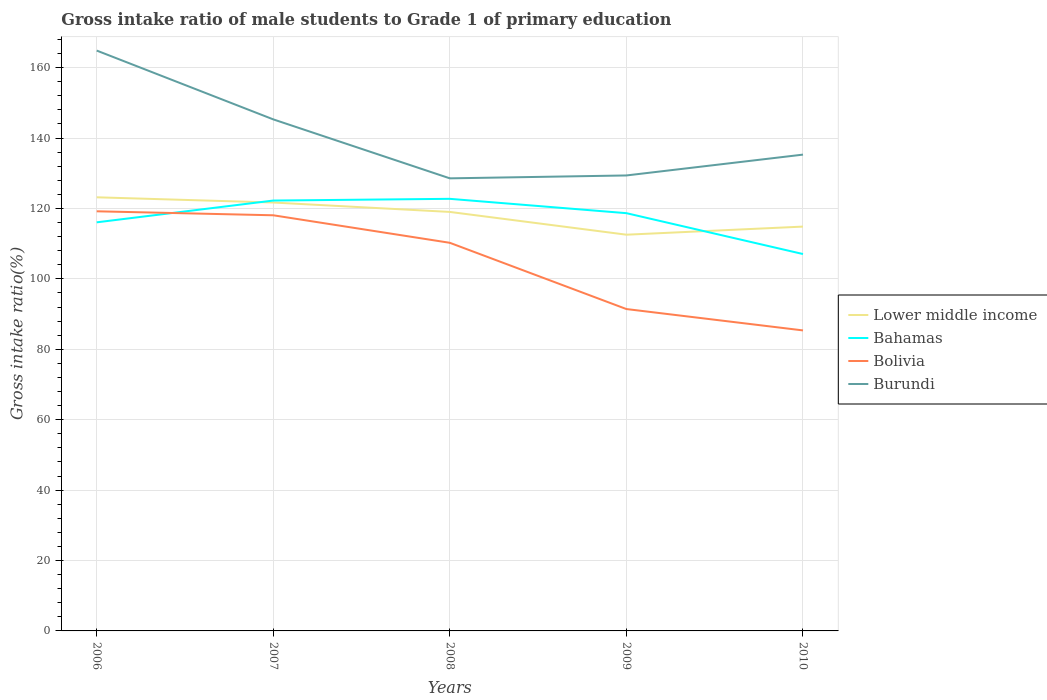How many different coloured lines are there?
Give a very brief answer. 4. Across all years, what is the maximum gross intake ratio in Lower middle income?
Make the answer very short. 112.54. In which year was the gross intake ratio in Bahamas maximum?
Your answer should be very brief. 2010. What is the total gross intake ratio in Lower middle income in the graph?
Ensure brevity in your answer.  9.14. What is the difference between the highest and the second highest gross intake ratio in Bolivia?
Provide a short and direct response. 33.83. Is the gross intake ratio in Bolivia strictly greater than the gross intake ratio in Lower middle income over the years?
Offer a very short reply. Yes. How many lines are there?
Provide a succinct answer. 4. Does the graph contain any zero values?
Offer a terse response. No. How many legend labels are there?
Ensure brevity in your answer.  4. What is the title of the graph?
Offer a terse response. Gross intake ratio of male students to Grade 1 of primary education. Does "Georgia" appear as one of the legend labels in the graph?
Your answer should be very brief. No. What is the label or title of the Y-axis?
Your answer should be very brief. Gross intake ratio(%). What is the Gross intake ratio(%) in Lower middle income in 2006?
Ensure brevity in your answer.  123.17. What is the Gross intake ratio(%) of Bahamas in 2006?
Your answer should be very brief. 116.06. What is the Gross intake ratio(%) in Bolivia in 2006?
Offer a terse response. 119.19. What is the Gross intake ratio(%) in Burundi in 2006?
Ensure brevity in your answer.  164.85. What is the Gross intake ratio(%) of Lower middle income in 2007?
Give a very brief answer. 121.68. What is the Gross intake ratio(%) of Bahamas in 2007?
Give a very brief answer. 122.25. What is the Gross intake ratio(%) in Bolivia in 2007?
Provide a short and direct response. 118.06. What is the Gross intake ratio(%) in Burundi in 2007?
Offer a very short reply. 145.3. What is the Gross intake ratio(%) of Lower middle income in 2008?
Keep it short and to the point. 119.01. What is the Gross intake ratio(%) in Bahamas in 2008?
Offer a terse response. 122.73. What is the Gross intake ratio(%) of Bolivia in 2008?
Your answer should be very brief. 110.24. What is the Gross intake ratio(%) of Burundi in 2008?
Your answer should be compact. 128.55. What is the Gross intake ratio(%) in Lower middle income in 2009?
Your response must be concise. 112.54. What is the Gross intake ratio(%) in Bahamas in 2009?
Provide a succinct answer. 118.66. What is the Gross intake ratio(%) of Bolivia in 2009?
Make the answer very short. 91.42. What is the Gross intake ratio(%) in Burundi in 2009?
Your answer should be compact. 129.37. What is the Gross intake ratio(%) of Lower middle income in 2010?
Offer a terse response. 114.85. What is the Gross intake ratio(%) in Bahamas in 2010?
Your answer should be very brief. 107.05. What is the Gross intake ratio(%) of Bolivia in 2010?
Give a very brief answer. 85.36. What is the Gross intake ratio(%) of Burundi in 2010?
Your answer should be compact. 135.29. Across all years, what is the maximum Gross intake ratio(%) in Lower middle income?
Make the answer very short. 123.17. Across all years, what is the maximum Gross intake ratio(%) of Bahamas?
Your answer should be compact. 122.73. Across all years, what is the maximum Gross intake ratio(%) of Bolivia?
Provide a short and direct response. 119.19. Across all years, what is the maximum Gross intake ratio(%) in Burundi?
Make the answer very short. 164.85. Across all years, what is the minimum Gross intake ratio(%) in Lower middle income?
Your answer should be very brief. 112.54. Across all years, what is the minimum Gross intake ratio(%) of Bahamas?
Your answer should be compact. 107.05. Across all years, what is the minimum Gross intake ratio(%) in Bolivia?
Offer a very short reply. 85.36. Across all years, what is the minimum Gross intake ratio(%) of Burundi?
Your answer should be compact. 128.55. What is the total Gross intake ratio(%) in Lower middle income in the graph?
Your answer should be compact. 591.25. What is the total Gross intake ratio(%) in Bahamas in the graph?
Give a very brief answer. 586.74. What is the total Gross intake ratio(%) in Bolivia in the graph?
Offer a very short reply. 524.27. What is the total Gross intake ratio(%) of Burundi in the graph?
Your answer should be compact. 703.36. What is the difference between the Gross intake ratio(%) of Lower middle income in 2006 and that in 2007?
Keep it short and to the point. 1.49. What is the difference between the Gross intake ratio(%) in Bahamas in 2006 and that in 2007?
Your answer should be compact. -6.19. What is the difference between the Gross intake ratio(%) in Bolivia in 2006 and that in 2007?
Offer a very short reply. 1.13. What is the difference between the Gross intake ratio(%) of Burundi in 2006 and that in 2007?
Keep it short and to the point. 19.55. What is the difference between the Gross intake ratio(%) in Lower middle income in 2006 and that in 2008?
Your answer should be compact. 4.16. What is the difference between the Gross intake ratio(%) of Bahamas in 2006 and that in 2008?
Offer a very short reply. -6.67. What is the difference between the Gross intake ratio(%) of Bolivia in 2006 and that in 2008?
Make the answer very short. 8.95. What is the difference between the Gross intake ratio(%) in Burundi in 2006 and that in 2008?
Provide a succinct answer. 36.29. What is the difference between the Gross intake ratio(%) of Lower middle income in 2006 and that in 2009?
Ensure brevity in your answer.  10.63. What is the difference between the Gross intake ratio(%) of Bahamas in 2006 and that in 2009?
Keep it short and to the point. -2.6. What is the difference between the Gross intake ratio(%) in Bolivia in 2006 and that in 2009?
Offer a terse response. 27.77. What is the difference between the Gross intake ratio(%) in Burundi in 2006 and that in 2009?
Offer a terse response. 35.47. What is the difference between the Gross intake ratio(%) in Lower middle income in 2006 and that in 2010?
Offer a terse response. 8.32. What is the difference between the Gross intake ratio(%) of Bahamas in 2006 and that in 2010?
Your answer should be compact. 9.01. What is the difference between the Gross intake ratio(%) in Bolivia in 2006 and that in 2010?
Keep it short and to the point. 33.83. What is the difference between the Gross intake ratio(%) of Burundi in 2006 and that in 2010?
Provide a succinct answer. 29.56. What is the difference between the Gross intake ratio(%) in Lower middle income in 2007 and that in 2008?
Provide a succinct answer. 2.67. What is the difference between the Gross intake ratio(%) of Bahamas in 2007 and that in 2008?
Provide a short and direct response. -0.48. What is the difference between the Gross intake ratio(%) of Bolivia in 2007 and that in 2008?
Your answer should be very brief. 7.82. What is the difference between the Gross intake ratio(%) of Burundi in 2007 and that in 2008?
Keep it short and to the point. 16.75. What is the difference between the Gross intake ratio(%) in Lower middle income in 2007 and that in 2009?
Your answer should be compact. 9.14. What is the difference between the Gross intake ratio(%) of Bahamas in 2007 and that in 2009?
Ensure brevity in your answer.  3.59. What is the difference between the Gross intake ratio(%) in Bolivia in 2007 and that in 2009?
Provide a succinct answer. 26.64. What is the difference between the Gross intake ratio(%) in Burundi in 2007 and that in 2009?
Make the answer very short. 15.92. What is the difference between the Gross intake ratio(%) in Lower middle income in 2007 and that in 2010?
Provide a succinct answer. 6.84. What is the difference between the Gross intake ratio(%) in Bahamas in 2007 and that in 2010?
Make the answer very short. 15.2. What is the difference between the Gross intake ratio(%) in Bolivia in 2007 and that in 2010?
Keep it short and to the point. 32.7. What is the difference between the Gross intake ratio(%) of Burundi in 2007 and that in 2010?
Offer a very short reply. 10.01. What is the difference between the Gross intake ratio(%) of Lower middle income in 2008 and that in 2009?
Give a very brief answer. 6.47. What is the difference between the Gross intake ratio(%) in Bahamas in 2008 and that in 2009?
Make the answer very short. 4.07. What is the difference between the Gross intake ratio(%) in Bolivia in 2008 and that in 2009?
Make the answer very short. 18.82. What is the difference between the Gross intake ratio(%) of Burundi in 2008 and that in 2009?
Your answer should be very brief. -0.82. What is the difference between the Gross intake ratio(%) in Lower middle income in 2008 and that in 2010?
Your answer should be compact. 4.17. What is the difference between the Gross intake ratio(%) of Bahamas in 2008 and that in 2010?
Your response must be concise. 15.68. What is the difference between the Gross intake ratio(%) of Bolivia in 2008 and that in 2010?
Make the answer very short. 24.88. What is the difference between the Gross intake ratio(%) in Burundi in 2008 and that in 2010?
Offer a terse response. -6.74. What is the difference between the Gross intake ratio(%) in Lower middle income in 2009 and that in 2010?
Give a very brief answer. -2.3. What is the difference between the Gross intake ratio(%) of Bahamas in 2009 and that in 2010?
Your response must be concise. 11.61. What is the difference between the Gross intake ratio(%) of Bolivia in 2009 and that in 2010?
Ensure brevity in your answer.  6.06. What is the difference between the Gross intake ratio(%) of Burundi in 2009 and that in 2010?
Give a very brief answer. -5.92. What is the difference between the Gross intake ratio(%) in Lower middle income in 2006 and the Gross intake ratio(%) in Bahamas in 2007?
Keep it short and to the point. 0.92. What is the difference between the Gross intake ratio(%) in Lower middle income in 2006 and the Gross intake ratio(%) in Bolivia in 2007?
Give a very brief answer. 5.11. What is the difference between the Gross intake ratio(%) in Lower middle income in 2006 and the Gross intake ratio(%) in Burundi in 2007?
Offer a very short reply. -22.13. What is the difference between the Gross intake ratio(%) in Bahamas in 2006 and the Gross intake ratio(%) in Bolivia in 2007?
Your response must be concise. -2. What is the difference between the Gross intake ratio(%) of Bahamas in 2006 and the Gross intake ratio(%) of Burundi in 2007?
Ensure brevity in your answer.  -29.24. What is the difference between the Gross intake ratio(%) in Bolivia in 2006 and the Gross intake ratio(%) in Burundi in 2007?
Offer a terse response. -26.11. What is the difference between the Gross intake ratio(%) of Lower middle income in 2006 and the Gross intake ratio(%) of Bahamas in 2008?
Give a very brief answer. 0.44. What is the difference between the Gross intake ratio(%) of Lower middle income in 2006 and the Gross intake ratio(%) of Bolivia in 2008?
Ensure brevity in your answer.  12.93. What is the difference between the Gross intake ratio(%) in Lower middle income in 2006 and the Gross intake ratio(%) in Burundi in 2008?
Your answer should be very brief. -5.38. What is the difference between the Gross intake ratio(%) in Bahamas in 2006 and the Gross intake ratio(%) in Bolivia in 2008?
Keep it short and to the point. 5.82. What is the difference between the Gross intake ratio(%) of Bahamas in 2006 and the Gross intake ratio(%) of Burundi in 2008?
Offer a very short reply. -12.49. What is the difference between the Gross intake ratio(%) of Bolivia in 2006 and the Gross intake ratio(%) of Burundi in 2008?
Make the answer very short. -9.36. What is the difference between the Gross intake ratio(%) in Lower middle income in 2006 and the Gross intake ratio(%) in Bahamas in 2009?
Make the answer very short. 4.51. What is the difference between the Gross intake ratio(%) in Lower middle income in 2006 and the Gross intake ratio(%) in Bolivia in 2009?
Provide a succinct answer. 31.75. What is the difference between the Gross intake ratio(%) of Lower middle income in 2006 and the Gross intake ratio(%) of Burundi in 2009?
Give a very brief answer. -6.2. What is the difference between the Gross intake ratio(%) in Bahamas in 2006 and the Gross intake ratio(%) in Bolivia in 2009?
Your response must be concise. 24.64. What is the difference between the Gross intake ratio(%) in Bahamas in 2006 and the Gross intake ratio(%) in Burundi in 2009?
Offer a terse response. -13.32. What is the difference between the Gross intake ratio(%) in Bolivia in 2006 and the Gross intake ratio(%) in Burundi in 2009?
Provide a succinct answer. -10.18. What is the difference between the Gross intake ratio(%) in Lower middle income in 2006 and the Gross intake ratio(%) in Bahamas in 2010?
Offer a very short reply. 16.12. What is the difference between the Gross intake ratio(%) in Lower middle income in 2006 and the Gross intake ratio(%) in Bolivia in 2010?
Your answer should be compact. 37.81. What is the difference between the Gross intake ratio(%) in Lower middle income in 2006 and the Gross intake ratio(%) in Burundi in 2010?
Your response must be concise. -12.12. What is the difference between the Gross intake ratio(%) of Bahamas in 2006 and the Gross intake ratio(%) of Bolivia in 2010?
Make the answer very short. 30.7. What is the difference between the Gross intake ratio(%) in Bahamas in 2006 and the Gross intake ratio(%) in Burundi in 2010?
Ensure brevity in your answer.  -19.23. What is the difference between the Gross intake ratio(%) in Bolivia in 2006 and the Gross intake ratio(%) in Burundi in 2010?
Your response must be concise. -16.1. What is the difference between the Gross intake ratio(%) of Lower middle income in 2007 and the Gross intake ratio(%) of Bahamas in 2008?
Provide a short and direct response. -1.05. What is the difference between the Gross intake ratio(%) in Lower middle income in 2007 and the Gross intake ratio(%) in Bolivia in 2008?
Your answer should be very brief. 11.44. What is the difference between the Gross intake ratio(%) in Lower middle income in 2007 and the Gross intake ratio(%) in Burundi in 2008?
Ensure brevity in your answer.  -6.87. What is the difference between the Gross intake ratio(%) in Bahamas in 2007 and the Gross intake ratio(%) in Bolivia in 2008?
Provide a succinct answer. 12.01. What is the difference between the Gross intake ratio(%) in Bahamas in 2007 and the Gross intake ratio(%) in Burundi in 2008?
Offer a terse response. -6.3. What is the difference between the Gross intake ratio(%) of Bolivia in 2007 and the Gross intake ratio(%) of Burundi in 2008?
Offer a very short reply. -10.49. What is the difference between the Gross intake ratio(%) in Lower middle income in 2007 and the Gross intake ratio(%) in Bahamas in 2009?
Offer a very short reply. 3.02. What is the difference between the Gross intake ratio(%) of Lower middle income in 2007 and the Gross intake ratio(%) of Bolivia in 2009?
Your answer should be very brief. 30.26. What is the difference between the Gross intake ratio(%) of Lower middle income in 2007 and the Gross intake ratio(%) of Burundi in 2009?
Give a very brief answer. -7.69. What is the difference between the Gross intake ratio(%) in Bahamas in 2007 and the Gross intake ratio(%) in Bolivia in 2009?
Keep it short and to the point. 30.82. What is the difference between the Gross intake ratio(%) of Bahamas in 2007 and the Gross intake ratio(%) of Burundi in 2009?
Your answer should be compact. -7.13. What is the difference between the Gross intake ratio(%) in Bolivia in 2007 and the Gross intake ratio(%) in Burundi in 2009?
Keep it short and to the point. -11.32. What is the difference between the Gross intake ratio(%) in Lower middle income in 2007 and the Gross intake ratio(%) in Bahamas in 2010?
Ensure brevity in your answer.  14.63. What is the difference between the Gross intake ratio(%) in Lower middle income in 2007 and the Gross intake ratio(%) in Bolivia in 2010?
Provide a short and direct response. 36.33. What is the difference between the Gross intake ratio(%) in Lower middle income in 2007 and the Gross intake ratio(%) in Burundi in 2010?
Make the answer very short. -13.61. What is the difference between the Gross intake ratio(%) of Bahamas in 2007 and the Gross intake ratio(%) of Bolivia in 2010?
Give a very brief answer. 36.89. What is the difference between the Gross intake ratio(%) in Bahamas in 2007 and the Gross intake ratio(%) in Burundi in 2010?
Provide a short and direct response. -13.04. What is the difference between the Gross intake ratio(%) of Bolivia in 2007 and the Gross intake ratio(%) of Burundi in 2010?
Offer a very short reply. -17.23. What is the difference between the Gross intake ratio(%) of Lower middle income in 2008 and the Gross intake ratio(%) of Bahamas in 2009?
Provide a short and direct response. 0.35. What is the difference between the Gross intake ratio(%) of Lower middle income in 2008 and the Gross intake ratio(%) of Bolivia in 2009?
Keep it short and to the point. 27.59. What is the difference between the Gross intake ratio(%) of Lower middle income in 2008 and the Gross intake ratio(%) of Burundi in 2009?
Offer a very short reply. -10.36. What is the difference between the Gross intake ratio(%) in Bahamas in 2008 and the Gross intake ratio(%) in Bolivia in 2009?
Offer a terse response. 31.31. What is the difference between the Gross intake ratio(%) in Bahamas in 2008 and the Gross intake ratio(%) in Burundi in 2009?
Your answer should be very brief. -6.64. What is the difference between the Gross intake ratio(%) of Bolivia in 2008 and the Gross intake ratio(%) of Burundi in 2009?
Make the answer very short. -19.13. What is the difference between the Gross intake ratio(%) in Lower middle income in 2008 and the Gross intake ratio(%) in Bahamas in 2010?
Make the answer very short. 11.96. What is the difference between the Gross intake ratio(%) in Lower middle income in 2008 and the Gross intake ratio(%) in Bolivia in 2010?
Give a very brief answer. 33.65. What is the difference between the Gross intake ratio(%) in Lower middle income in 2008 and the Gross intake ratio(%) in Burundi in 2010?
Provide a succinct answer. -16.28. What is the difference between the Gross intake ratio(%) of Bahamas in 2008 and the Gross intake ratio(%) of Bolivia in 2010?
Provide a succinct answer. 37.37. What is the difference between the Gross intake ratio(%) in Bahamas in 2008 and the Gross intake ratio(%) in Burundi in 2010?
Offer a terse response. -12.56. What is the difference between the Gross intake ratio(%) in Bolivia in 2008 and the Gross intake ratio(%) in Burundi in 2010?
Keep it short and to the point. -25.05. What is the difference between the Gross intake ratio(%) in Lower middle income in 2009 and the Gross intake ratio(%) in Bahamas in 2010?
Your answer should be very brief. 5.49. What is the difference between the Gross intake ratio(%) of Lower middle income in 2009 and the Gross intake ratio(%) of Bolivia in 2010?
Give a very brief answer. 27.19. What is the difference between the Gross intake ratio(%) of Lower middle income in 2009 and the Gross intake ratio(%) of Burundi in 2010?
Offer a very short reply. -22.75. What is the difference between the Gross intake ratio(%) of Bahamas in 2009 and the Gross intake ratio(%) of Bolivia in 2010?
Provide a short and direct response. 33.3. What is the difference between the Gross intake ratio(%) of Bahamas in 2009 and the Gross intake ratio(%) of Burundi in 2010?
Your answer should be very brief. -16.63. What is the difference between the Gross intake ratio(%) in Bolivia in 2009 and the Gross intake ratio(%) in Burundi in 2010?
Ensure brevity in your answer.  -43.87. What is the average Gross intake ratio(%) of Lower middle income per year?
Offer a very short reply. 118.25. What is the average Gross intake ratio(%) in Bahamas per year?
Your response must be concise. 117.35. What is the average Gross intake ratio(%) of Bolivia per year?
Keep it short and to the point. 104.85. What is the average Gross intake ratio(%) of Burundi per year?
Ensure brevity in your answer.  140.67. In the year 2006, what is the difference between the Gross intake ratio(%) in Lower middle income and Gross intake ratio(%) in Bahamas?
Ensure brevity in your answer.  7.11. In the year 2006, what is the difference between the Gross intake ratio(%) in Lower middle income and Gross intake ratio(%) in Bolivia?
Your answer should be very brief. 3.98. In the year 2006, what is the difference between the Gross intake ratio(%) in Lower middle income and Gross intake ratio(%) in Burundi?
Keep it short and to the point. -41.68. In the year 2006, what is the difference between the Gross intake ratio(%) of Bahamas and Gross intake ratio(%) of Bolivia?
Your response must be concise. -3.13. In the year 2006, what is the difference between the Gross intake ratio(%) of Bahamas and Gross intake ratio(%) of Burundi?
Offer a very short reply. -48.79. In the year 2006, what is the difference between the Gross intake ratio(%) in Bolivia and Gross intake ratio(%) in Burundi?
Keep it short and to the point. -45.65. In the year 2007, what is the difference between the Gross intake ratio(%) of Lower middle income and Gross intake ratio(%) of Bahamas?
Your answer should be very brief. -0.56. In the year 2007, what is the difference between the Gross intake ratio(%) of Lower middle income and Gross intake ratio(%) of Bolivia?
Your response must be concise. 3.62. In the year 2007, what is the difference between the Gross intake ratio(%) of Lower middle income and Gross intake ratio(%) of Burundi?
Your response must be concise. -23.62. In the year 2007, what is the difference between the Gross intake ratio(%) in Bahamas and Gross intake ratio(%) in Bolivia?
Make the answer very short. 4.19. In the year 2007, what is the difference between the Gross intake ratio(%) of Bahamas and Gross intake ratio(%) of Burundi?
Offer a very short reply. -23.05. In the year 2007, what is the difference between the Gross intake ratio(%) in Bolivia and Gross intake ratio(%) in Burundi?
Give a very brief answer. -27.24. In the year 2008, what is the difference between the Gross intake ratio(%) in Lower middle income and Gross intake ratio(%) in Bahamas?
Make the answer very short. -3.72. In the year 2008, what is the difference between the Gross intake ratio(%) of Lower middle income and Gross intake ratio(%) of Bolivia?
Provide a succinct answer. 8.77. In the year 2008, what is the difference between the Gross intake ratio(%) in Lower middle income and Gross intake ratio(%) in Burundi?
Your answer should be very brief. -9.54. In the year 2008, what is the difference between the Gross intake ratio(%) of Bahamas and Gross intake ratio(%) of Bolivia?
Provide a short and direct response. 12.49. In the year 2008, what is the difference between the Gross intake ratio(%) of Bahamas and Gross intake ratio(%) of Burundi?
Your response must be concise. -5.82. In the year 2008, what is the difference between the Gross intake ratio(%) of Bolivia and Gross intake ratio(%) of Burundi?
Your answer should be very brief. -18.31. In the year 2009, what is the difference between the Gross intake ratio(%) in Lower middle income and Gross intake ratio(%) in Bahamas?
Offer a terse response. -6.12. In the year 2009, what is the difference between the Gross intake ratio(%) of Lower middle income and Gross intake ratio(%) of Bolivia?
Provide a short and direct response. 21.12. In the year 2009, what is the difference between the Gross intake ratio(%) in Lower middle income and Gross intake ratio(%) in Burundi?
Offer a very short reply. -16.83. In the year 2009, what is the difference between the Gross intake ratio(%) of Bahamas and Gross intake ratio(%) of Bolivia?
Provide a succinct answer. 27.24. In the year 2009, what is the difference between the Gross intake ratio(%) in Bahamas and Gross intake ratio(%) in Burundi?
Provide a short and direct response. -10.72. In the year 2009, what is the difference between the Gross intake ratio(%) in Bolivia and Gross intake ratio(%) in Burundi?
Provide a short and direct response. -37.95. In the year 2010, what is the difference between the Gross intake ratio(%) of Lower middle income and Gross intake ratio(%) of Bahamas?
Provide a short and direct response. 7.8. In the year 2010, what is the difference between the Gross intake ratio(%) of Lower middle income and Gross intake ratio(%) of Bolivia?
Keep it short and to the point. 29.49. In the year 2010, what is the difference between the Gross intake ratio(%) in Lower middle income and Gross intake ratio(%) in Burundi?
Your response must be concise. -20.44. In the year 2010, what is the difference between the Gross intake ratio(%) of Bahamas and Gross intake ratio(%) of Bolivia?
Ensure brevity in your answer.  21.69. In the year 2010, what is the difference between the Gross intake ratio(%) in Bahamas and Gross intake ratio(%) in Burundi?
Your answer should be very brief. -28.24. In the year 2010, what is the difference between the Gross intake ratio(%) of Bolivia and Gross intake ratio(%) of Burundi?
Offer a very short reply. -49.93. What is the ratio of the Gross intake ratio(%) of Lower middle income in 2006 to that in 2007?
Give a very brief answer. 1.01. What is the ratio of the Gross intake ratio(%) in Bahamas in 2006 to that in 2007?
Give a very brief answer. 0.95. What is the ratio of the Gross intake ratio(%) of Bolivia in 2006 to that in 2007?
Your response must be concise. 1.01. What is the ratio of the Gross intake ratio(%) in Burundi in 2006 to that in 2007?
Give a very brief answer. 1.13. What is the ratio of the Gross intake ratio(%) in Lower middle income in 2006 to that in 2008?
Offer a very short reply. 1.03. What is the ratio of the Gross intake ratio(%) in Bahamas in 2006 to that in 2008?
Make the answer very short. 0.95. What is the ratio of the Gross intake ratio(%) in Bolivia in 2006 to that in 2008?
Ensure brevity in your answer.  1.08. What is the ratio of the Gross intake ratio(%) of Burundi in 2006 to that in 2008?
Offer a terse response. 1.28. What is the ratio of the Gross intake ratio(%) of Lower middle income in 2006 to that in 2009?
Make the answer very short. 1.09. What is the ratio of the Gross intake ratio(%) of Bahamas in 2006 to that in 2009?
Your answer should be compact. 0.98. What is the ratio of the Gross intake ratio(%) of Bolivia in 2006 to that in 2009?
Offer a terse response. 1.3. What is the ratio of the Gross intake ratio(%) in Burundi in 2006 to that in 2009?
Your answer should be compact. 1.27. What is the ratio of the Gross intake ratio(%) of Lower middle income in 2006 to that in 2010?
Provide a succinct answer. 1.07. What is the ratio of the Gross intake ratio(%) in Bahamas in 2006 to that in 2010?
Ensure brevity in your answer.  1.08. What is the ratio of the Gross intake ratio(%) in Bolivia in 2006 to that in 2010?
Offer a very short reply. 1.4. What is the ratio of the Gross intake ratio(%) in Burundi in 2006 to that in 2010?
Your answer should be very brief. 1.22. What is the ratio of the Gross intake ratio(%) in Lower middle income in 2007 to that in 2008?
Make the answer very short. 1.02. What is the ratio of the Gross intake ratio(%) of Bahamas in 2007 to that in 2008?
Offer a very short reply. 1. What is the ratio of the Gross intake ratio(%) of Bolivia in 2007 to that in 2008?
Your answer should be very brief. 1.07. What is the ratio of the Gross intake ratio(%) of Burundi in 2007 to that in 2008?
Offer a very short reply. 1.13. What is the ratio of the Gross intake ratio(%) of Lower middle income in 2007 to that in 2009?
Provide a short and direct response. 1.08. What is the ratio of the Gross intake ratio(%) of Bahamas in 2007 to that in 2009?
Keep it short and to the point. 1.03. What is the ratio of the Gross intake ratio(%) of Bolivia in 2007 to that in 2009?
Provide a short and direct response. 1.29. What is the ratio of the Gross intake ratio(%) in Burundi in 2007 to that in 2009?
Offer a very short reply. 1.12. What is the ratio of the Gross intake ratio(%) of Lower middle income in 2007 to that in 2010?
Give a very brief answer. 1.06. What is the ratio of the Gross intake ratio(%) of Bahamas in 2007 to that in 2010?
Provide a succinct answer. 1.14. What is the ratio of the Gross intake ratio(%) in Bolivia in 2007 to that in 2010?
Give a very brief answer. 1.38. What is the ratio of the Gross intake ratio(%) of Burundi in 2007 to that in 2010?
Your response must be concise. 1.07. What is the ratio of the Gross intake ratio(%) of Lower middle income in 2008 to that in 2009?
Make the answer very short. 1.06. What is the ratio of the Gross intake ratio(%) of Bahamas in 2008 to that in 2009?
Ensure brevity in your answer.  1.03. What is the ratio of the Gross intake ratio(%) in Bolivia in 2008 to that in 2009?
Give a very brief answer. 1.21. What is the ratio of the Gross intake ratio(%) of Burundi in 2008 to that in 2009?
Provide a short and direct response. 0.99. What is the ratio of the Gross intake ratio(%) of Lower middle income in 2008 to that in 2010?
Keep it short and to the point. 1.04. What is the ratio of the Gross intake ratio(%) in Bahamas in 2008 to that in 2010?
Keep it short and to the point. 1.15. What is the ratio of the Gross intake ratio(%) in Bolivia in 2008 to that in 2010?
Offer a terse response. 1.29. What is the ratio of the Gross intake ratio(%) in Burundi in 2008 to that in 2010?
Ensure brevity in your answer.  0.95. What is the ratio of the Gross intake ratio(%) of Lower middle income in 2009 to that in 2010?
Offer a terse response. 0.98. What is the ratio of the Gross intake ratio(%) of Bahamas in 2009 to that in 2010?
Your response must be concise. 1.11. What is the ratio of the Gross intake ratio(%) of Bolivia in 2009 to that in 2010?
Offer a very short reply. 1.07. What is the ratio of the Gross intake ratio(%) in Burundi in 2009 to that in 2010?
Give a very brief answer. 0.96. What is the difference between the highest and the second highest Gross intake ratio(%) of Lower middle income?
Provide a short and direct response. 1.49. What is the difference between the highest and the second highest Gross intake ratio(%) of Bahamas?
Provide a succinct answer. 0.48. What is the difference between the highest and the second highest Gross intake ratio(%) of Bolivia?
Provide a succinct answer. 1.13. What is the difference between the highest and the second highest Gross intake ratio(%) in Burundi?
Provide a short and direct response. 19.55. What is the difference between the highest and the lowest Gross intake ratio(%) of Lower middle income?
Give a very brief answer. 10.63. What is the difference between the highest and the lowest Gross intake ratio(%) of Bahamas?
Your response must be concise. 15.68. What is the difference between the highest and the lowest Gross intake ratio(%) of Bolivia?
Your answer should be very brief. 33.83. What is the difference between the highest and the lowest Gross intake ratio(%) of Burundi?
Your answer should be compact. 36.29. 